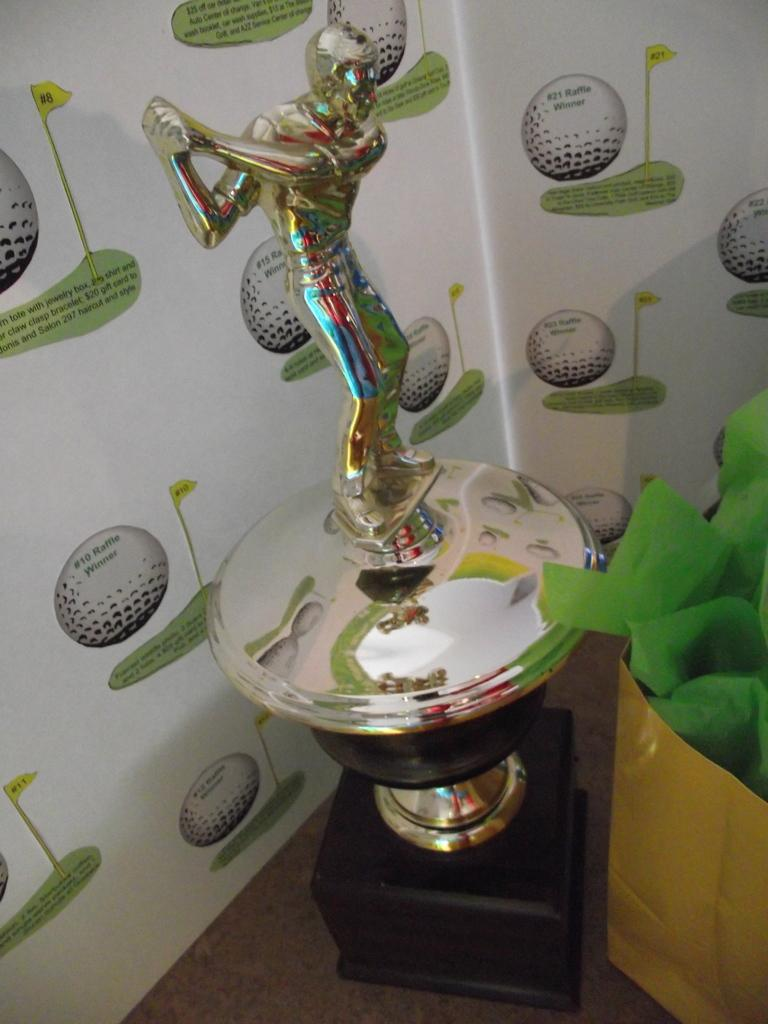What is the main object in the image? There is a trophy in the image. What else can be seen in the image besides the trophy? There is a bag with papers in the image. Where is the bag with papers located? The bag with papers is placed on a surface. What can be seen in the background of the image? There is a banner in the background of the image. What is on the banner? The banner has pictures and text on it. What type of insurance is advertised on the banner in the image? There is no insurance mentioned or advertised on the banner in the image. What vegetable is depicted on the banner in the image? There are no vegetables depicted on the banner in the image. 